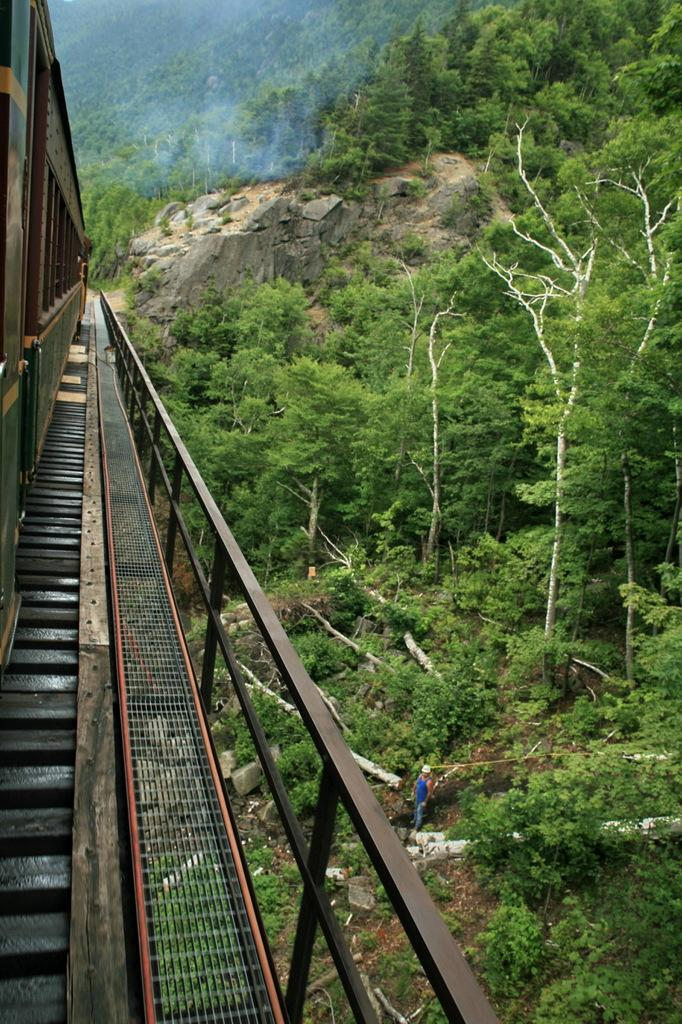What is the main subject of the image? The main subject of the image is a train. Where is the train located in the image? The train is on a railway track. What can be seen beside the train? There is a fence visible beside the train. Who or what else is present in the image? A person is present in the image. What type of natural elements can be seen in the image? Trees and rocks are present in the image. What type of paper is the person holding in the image? There is no paper visible in the image; the person is not holding anything. 